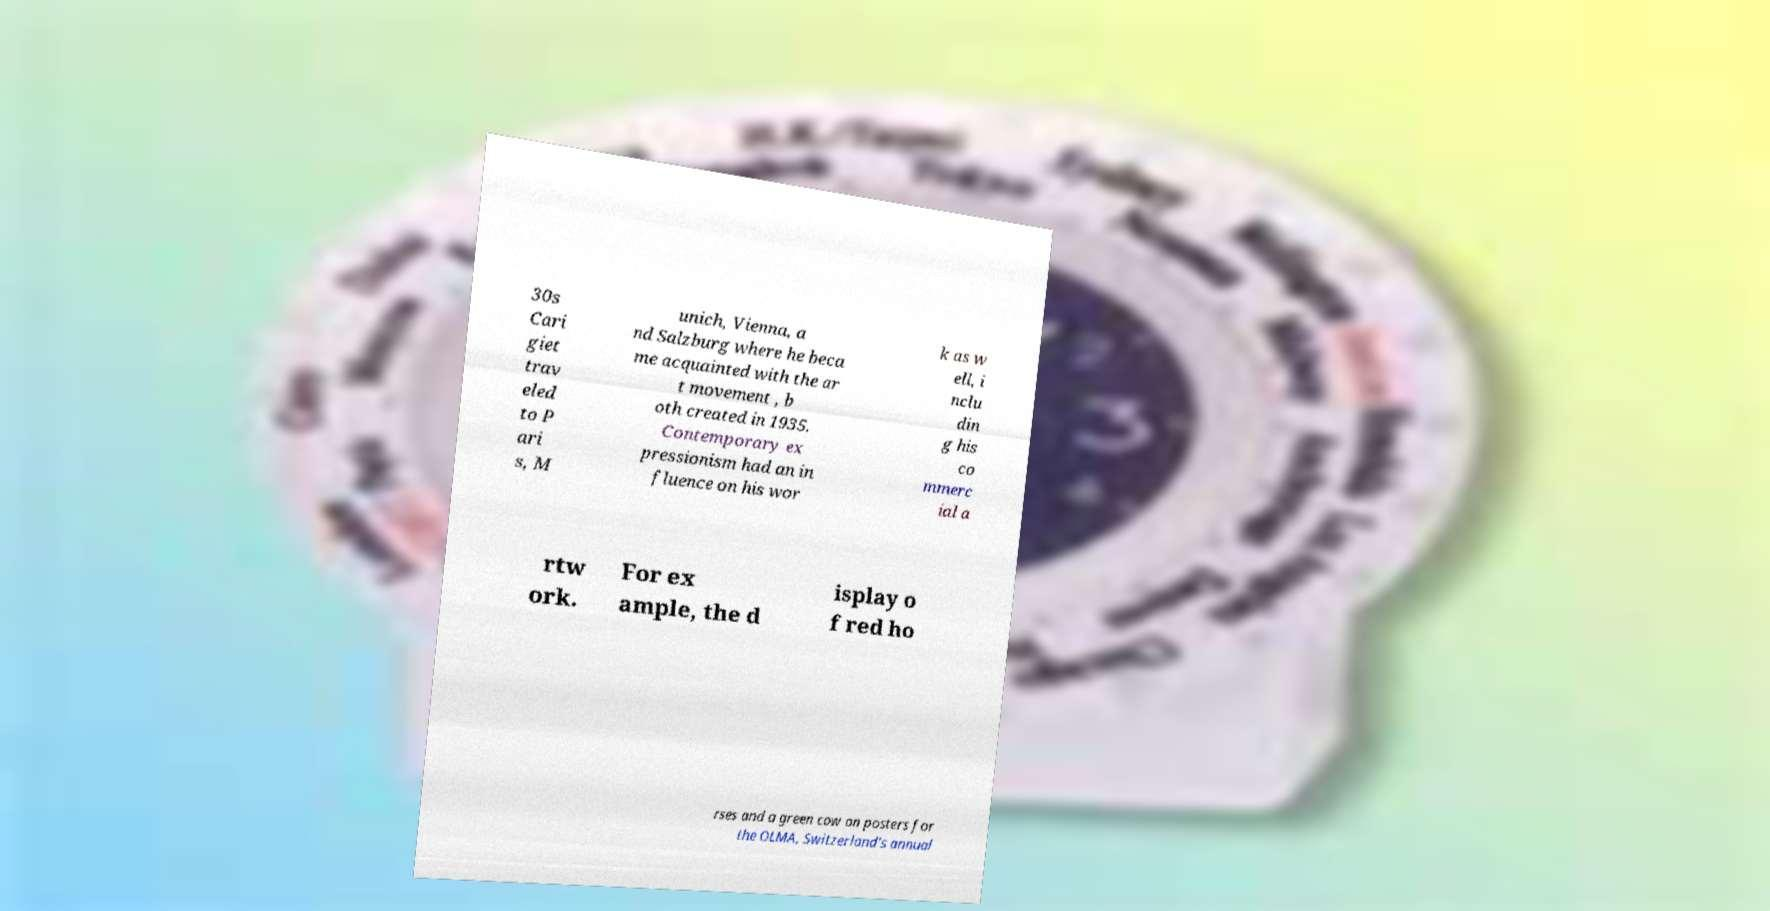For documentation purposes, I need the text within this image transcribed. Could you provide that? 30s Cari giet trav eled to P ari s, M unich, Vienna, a nd Salzburg where he beca me acquainted with the ar t movement , b oth created in 1935. Contemporary ex pressionism had an in fluence on his wor k as w ell, i nclu din g his co mmerc ial a rtw ork. For ex ample, the d isplay o f red ho rses and a green cow on posters for the OLMA, Switzerland’s annual 